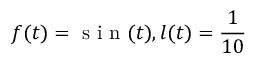<formula> <loc_0><loc_0><loc_500><loc_500>f ( t ) = s i n ( t ) , l ( t ) = \frac { 1 } { 1 0 }</formula> 